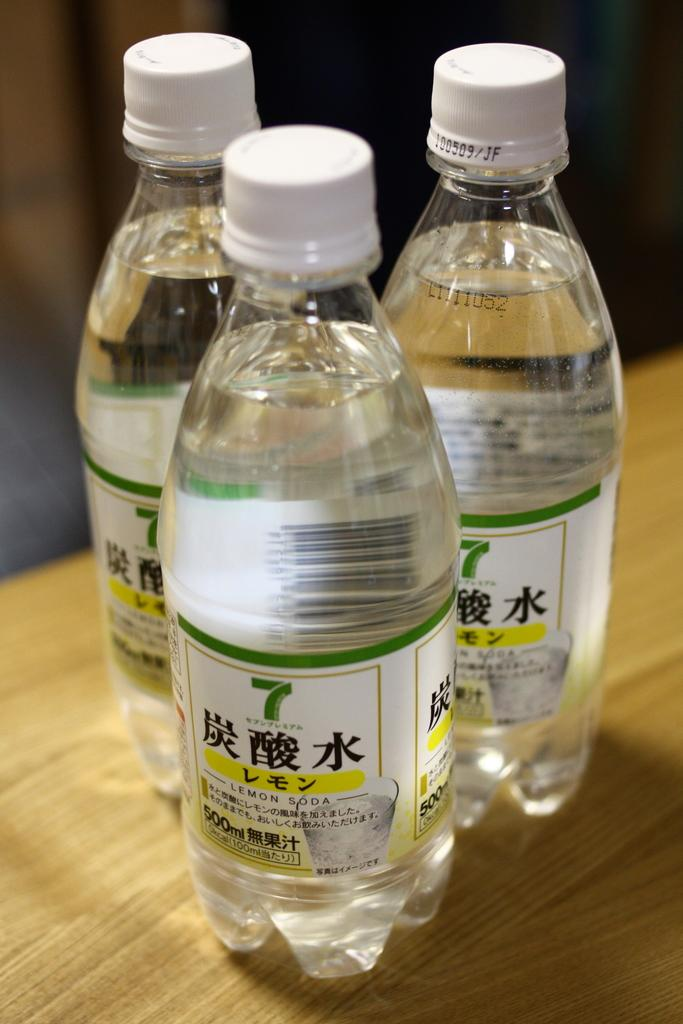<image>
Create a compact narrative representing the image presented. Bottles of Lemon Soda sitting on a table 500 ml each. 